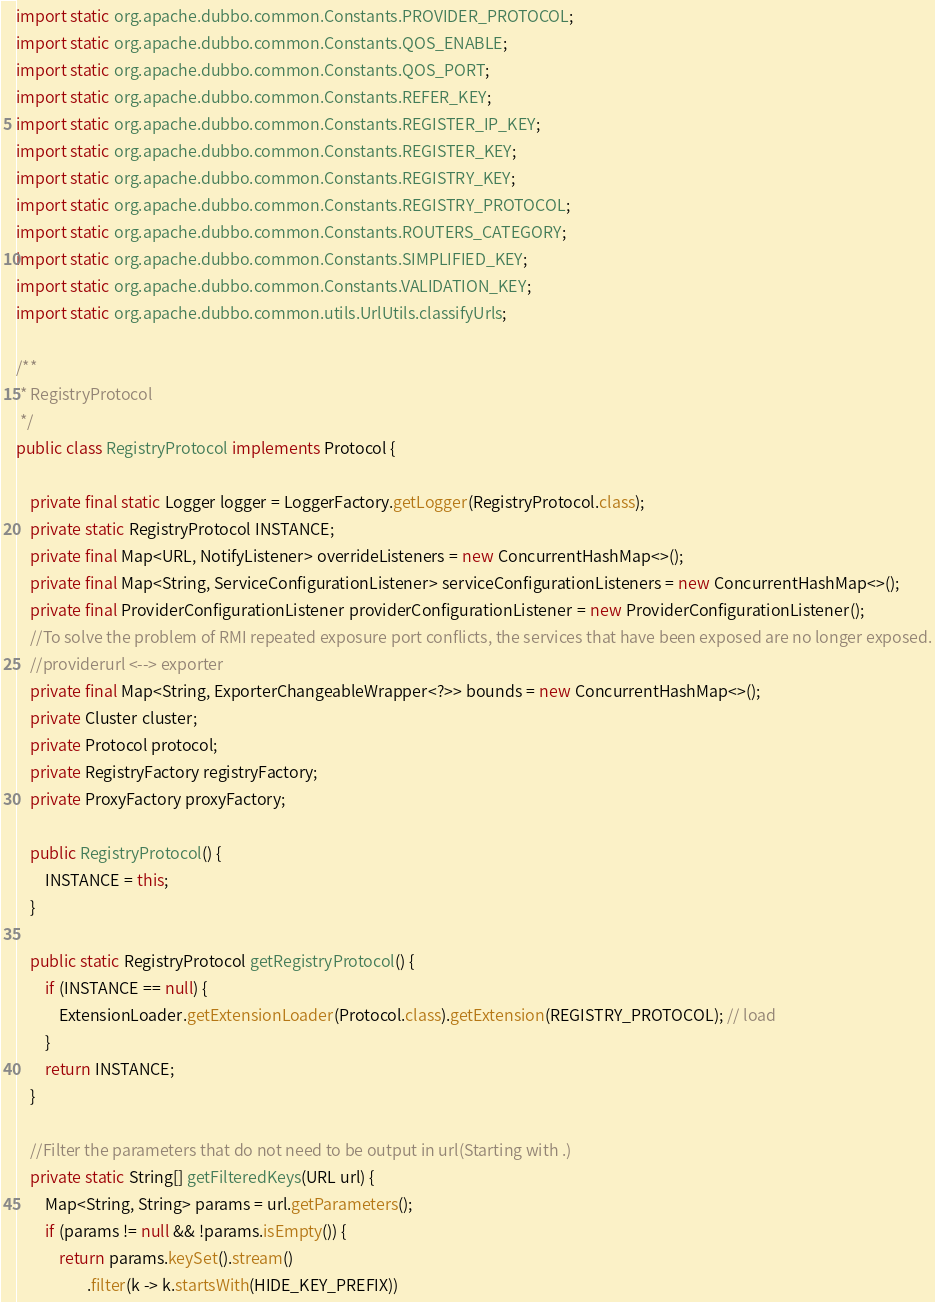<code> <loc_0><loc_0><loc_500><loc_500><_Java_>import static org.apache.dubbo.common.Constants.PROVIDER_PROTOCOL;
import static org.apache.dubbo.common.Constants.QOS_ENABLE;
import static org.apache.dubbo.common.Constants.QOS_PORT;
import static org.apache.dubbo.common.Constants.REFER_KEY;
import static org.apache.dubbo.common.Constants.REGISTER_IP_KEY;
import static org.apache.dubbo.common.Constants.REGISTER_KEY;
import static org.apache.dubbo.common.Constants.REGISTRY_KEY;
import static org.apache.dubbo.common.Constants.REGISTRY_PROTOCOL;
import static org.apache.dubbo.common.Constants.ROUTERS_CATEGORY;
import static org.apache.dubbo.common.Constants.SIMPLIFIED_KEY;
import static org.apache.dubbo.common.Constants.VALIDATION_KEY;
import static org.apache.dubbo.common.utils.UrlUtils.classifyUrls;

/**
 * RegistryProtocol
 */
public class RegistryProtocol implements Protocol {

    private final static Logger logger = LoggerFactory.getLogger(RegistryProtocol.class);
    private static RegistryProtocol INSTANCE;
    private final Map<URL, NotifyListener> overrideListeners = new ConcurrentHashMap<>();
    private final Map<String, ServiceConfigurationListener> serviceConfigurationListeners = new ConcurrentHashMap<>();
    private final ProviderConfigurationListener providerConfigurationListener = new ProviderConfigurationListener();
    //To solve the problem of RMI repeated exposure port conflicts, the services that have been exposed are no longer exposed.
    //providerurl <--> exporter
    private final Map<String, ExporterChangeableWrapper<?>> bounds = new ConcurrentHashMap<>();
    private Cluster cluster;
    private Protocol protocol;
    private RegistryFactory registryFactory;
    private ProxyFactory proxyFactory;

    public RegistryProtocol() {
        INSTANCE = this;
    }

    public static RegistryProtocol getRegistryProtocol() {
        if (INSTANCE == null) {
            ExtensionLoader.getExtensionLoader(Protocol.class).getExtension(REGISTRY_PROTOCOL); // load
        }
        return INSTANCE;
    }

    //Filter the parameters that do not need to be output in url(Starting with .)
    private static String[] getFilteredKeys(URL url) {
        Map<String, String> params = url.getParameters();
        if (params != null && !params.isEmpty()) {
            return params.keySet().stream()
                    .filter(k -> k.startsWith(HIDE_KEY_PREFIX))</code> 